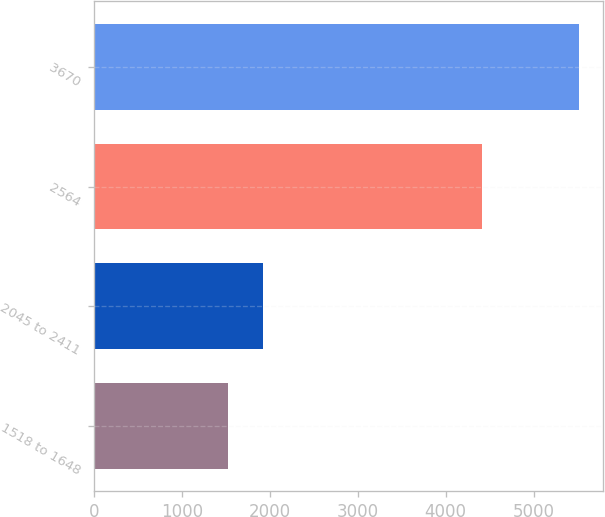Convert chart. <chart><loc_0><loc_0><loc_500><loc_500><bar_chart><fcel>1518 to 1648<fcel>2045 to 2411<fcel>2564<fcel>3670<nl><fcel>1521<fcel>1920<fcel>4409<fcel>5511<nl></chart> 